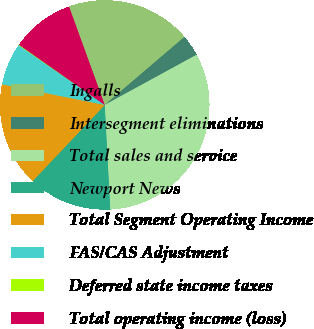Convert chart to OTSL. <chart><loc_0><loc_0><loc_500><loc_500><pie_chart><fcel>Ingalls<fcel>Intersegment eliminations<fcel>Total sales and service<fcel>Newport News<fcel>Total Segment Operating Income<fcel>FAS/CAS Adjustment<fcel>Deferred state income taxes<fcel>Total operating income (loss)<nl><fcel>19.3%<fcel>3.29%<fcel>32.11%<fcel>12.9%<fcel>16.1%<fcel>6.5%<fcel>0.09%<fcel>9.7%<nl></chart> 